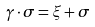<formula> <loc_0><loc_0><loc_500><loc_500>\gamma \cdot \sigma = \xi + \sigma</formula> 